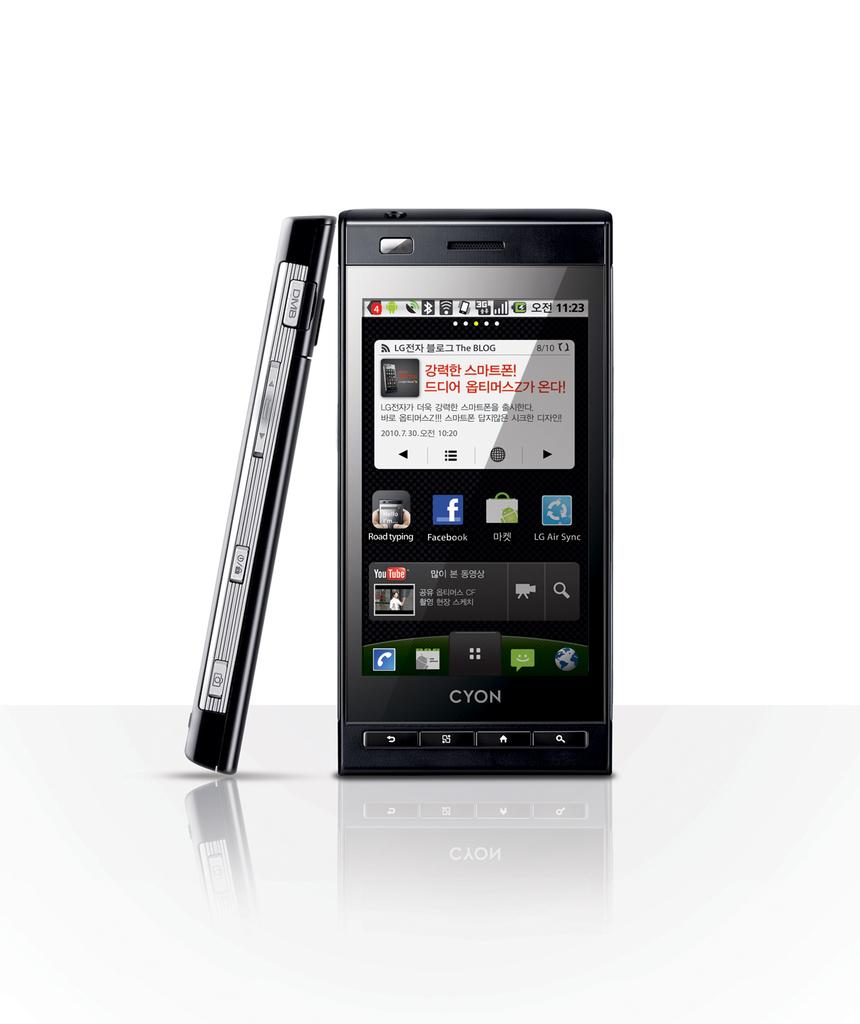What time is displayed in the upper right corner?
Provide a short and direct response. 11:23. 